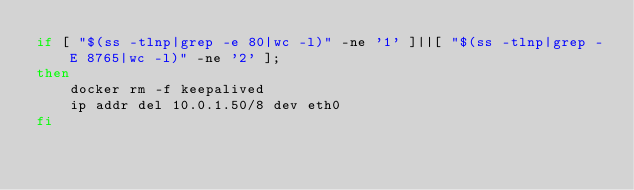<code> <loc_0><loc_0><loc_500><loc_500><_Bash_>if [ "$(ss -tlnp|grep -e 80|wc -l)" -ne '1' ]||[ "$(ss -tlnp|grep -E 8765|wc -l)" -ne '2' ];
then
    docker rm -f keepalived
    ip addr del 10.0.1.50/8 dev eth0
fi
</code> 